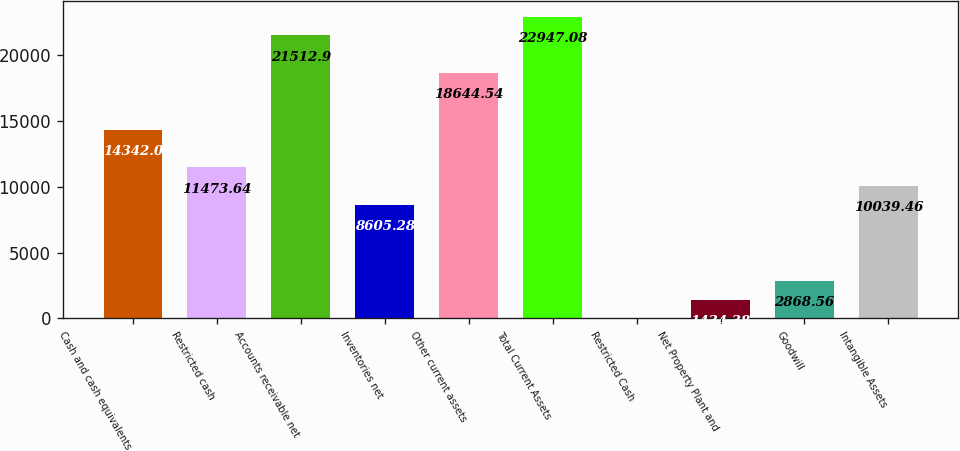<chart> <loc_0><loc_0><loc_500><loc_500><bar_chart><fcel>Cash and cash equivalents<fcel>Restricted cash<fcel>Accounts receivable net<fcel>Inventories net<fcel>Other current assets<fcel>Total Current Assets<fcel>Restricted Cash<fcel>Net Property Plant and<fcel>Goodwill<fcel>Intangible Assets<nl><fcel>14342<fcel>11473.6<fcel>21512.9<fcel>8605.28<fcel>18644.5<fcel>22947.1<fcel>0.2<fcel>1434.38<fcel>2868.56<fcel>10039.5<nl></chart> 